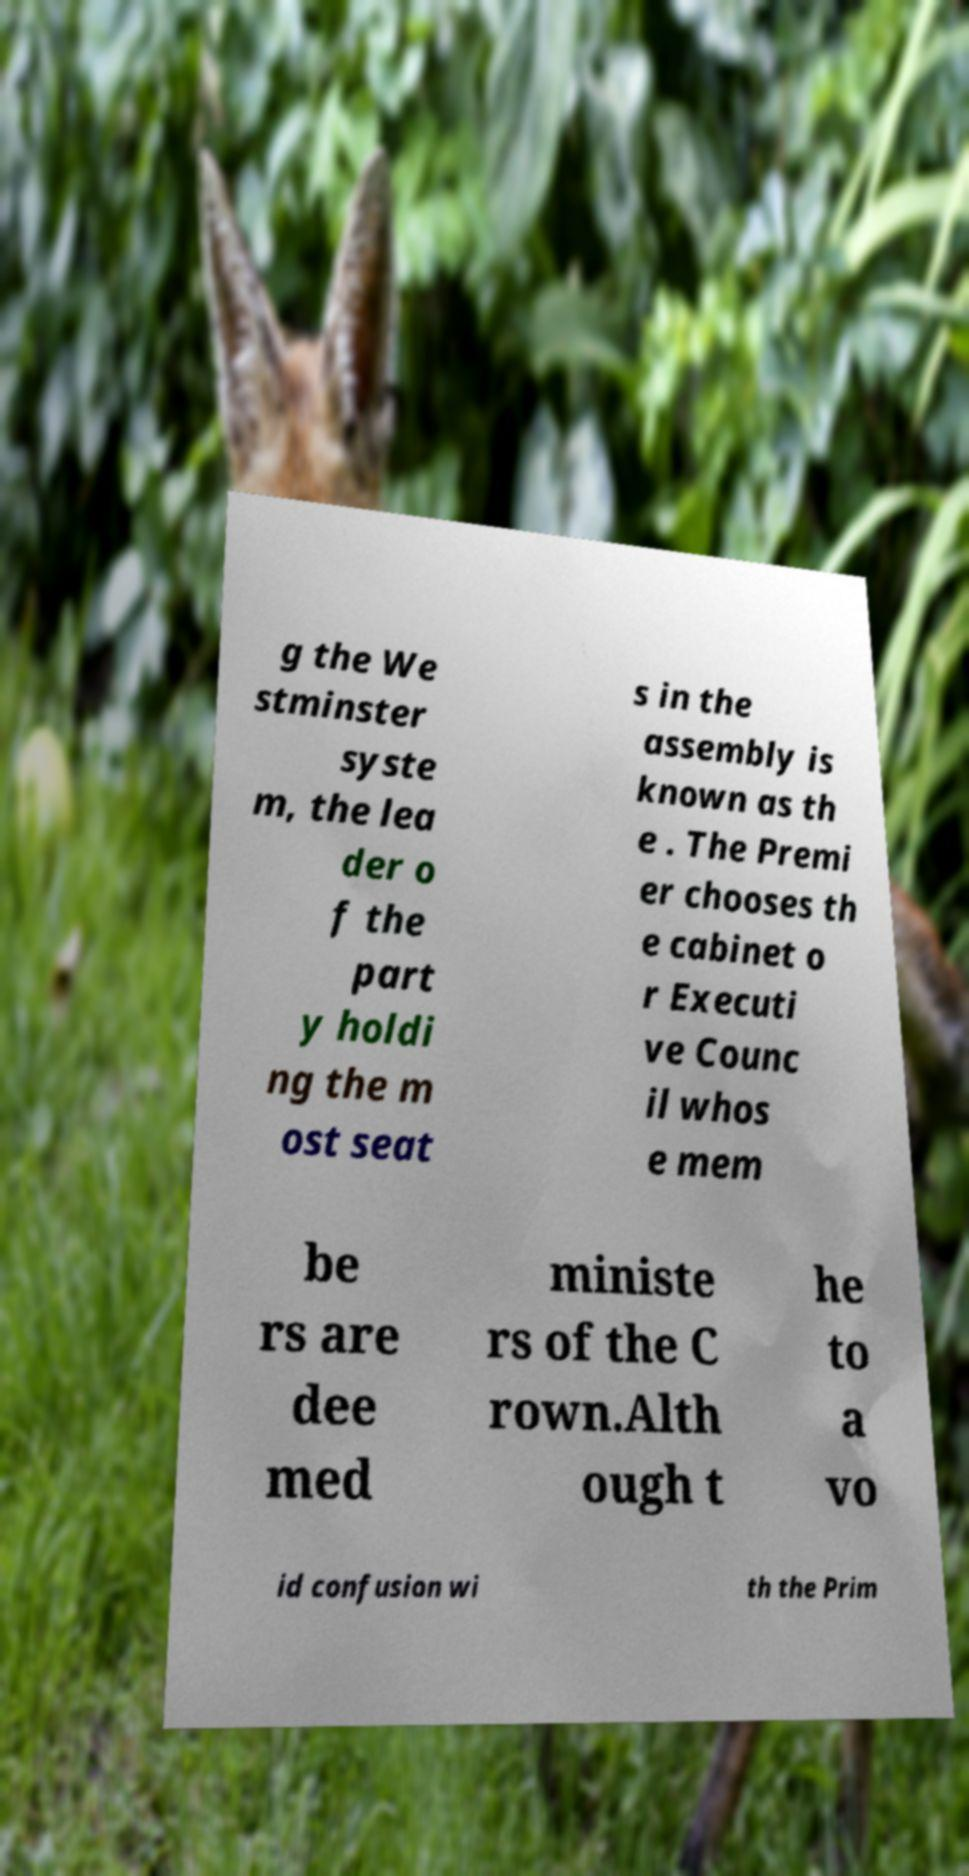Can you read and provide the text displayed in the image?This photo seems to have some interesting text. Can you extract and type it out for me? g the We stminster syste m, the lea der o f the part y holdi ng the m ost seat s in the assembly is known as th e . The Premi er chooses th e cabinet o r Executi ve Counc il whos e mem be rs are dee med ministe rs of the C rown.Alth ough t he to a vo id confusion wi th the Prim 